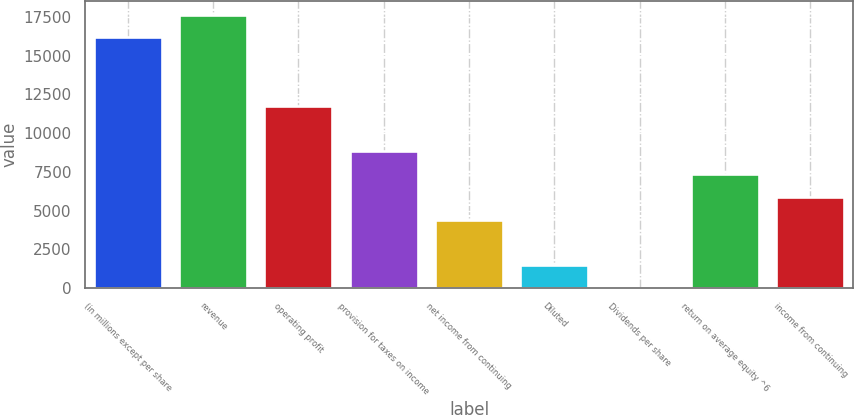Convert chart to OTSL. <chart><loc_0><loc_0><loc_500><loc_500><bar_chart><fcel>(in millions except per share<fcel>revenue<fcel>operating profit<fcel>provision for taxes on income<fcel>net income from continuing<fcel>Diluted<fcel>Dividends per share<fcel>return on average equity ^6<fcel>income from continuing<nl><fcel>16169.9<fcel>17639.8<fcel>11760.2<fcel>8820.36<fcel>4410.63<fcel>1470.81<fcel>0.9<fcel>7350.45<fcel>5880.54<nl></chart> 